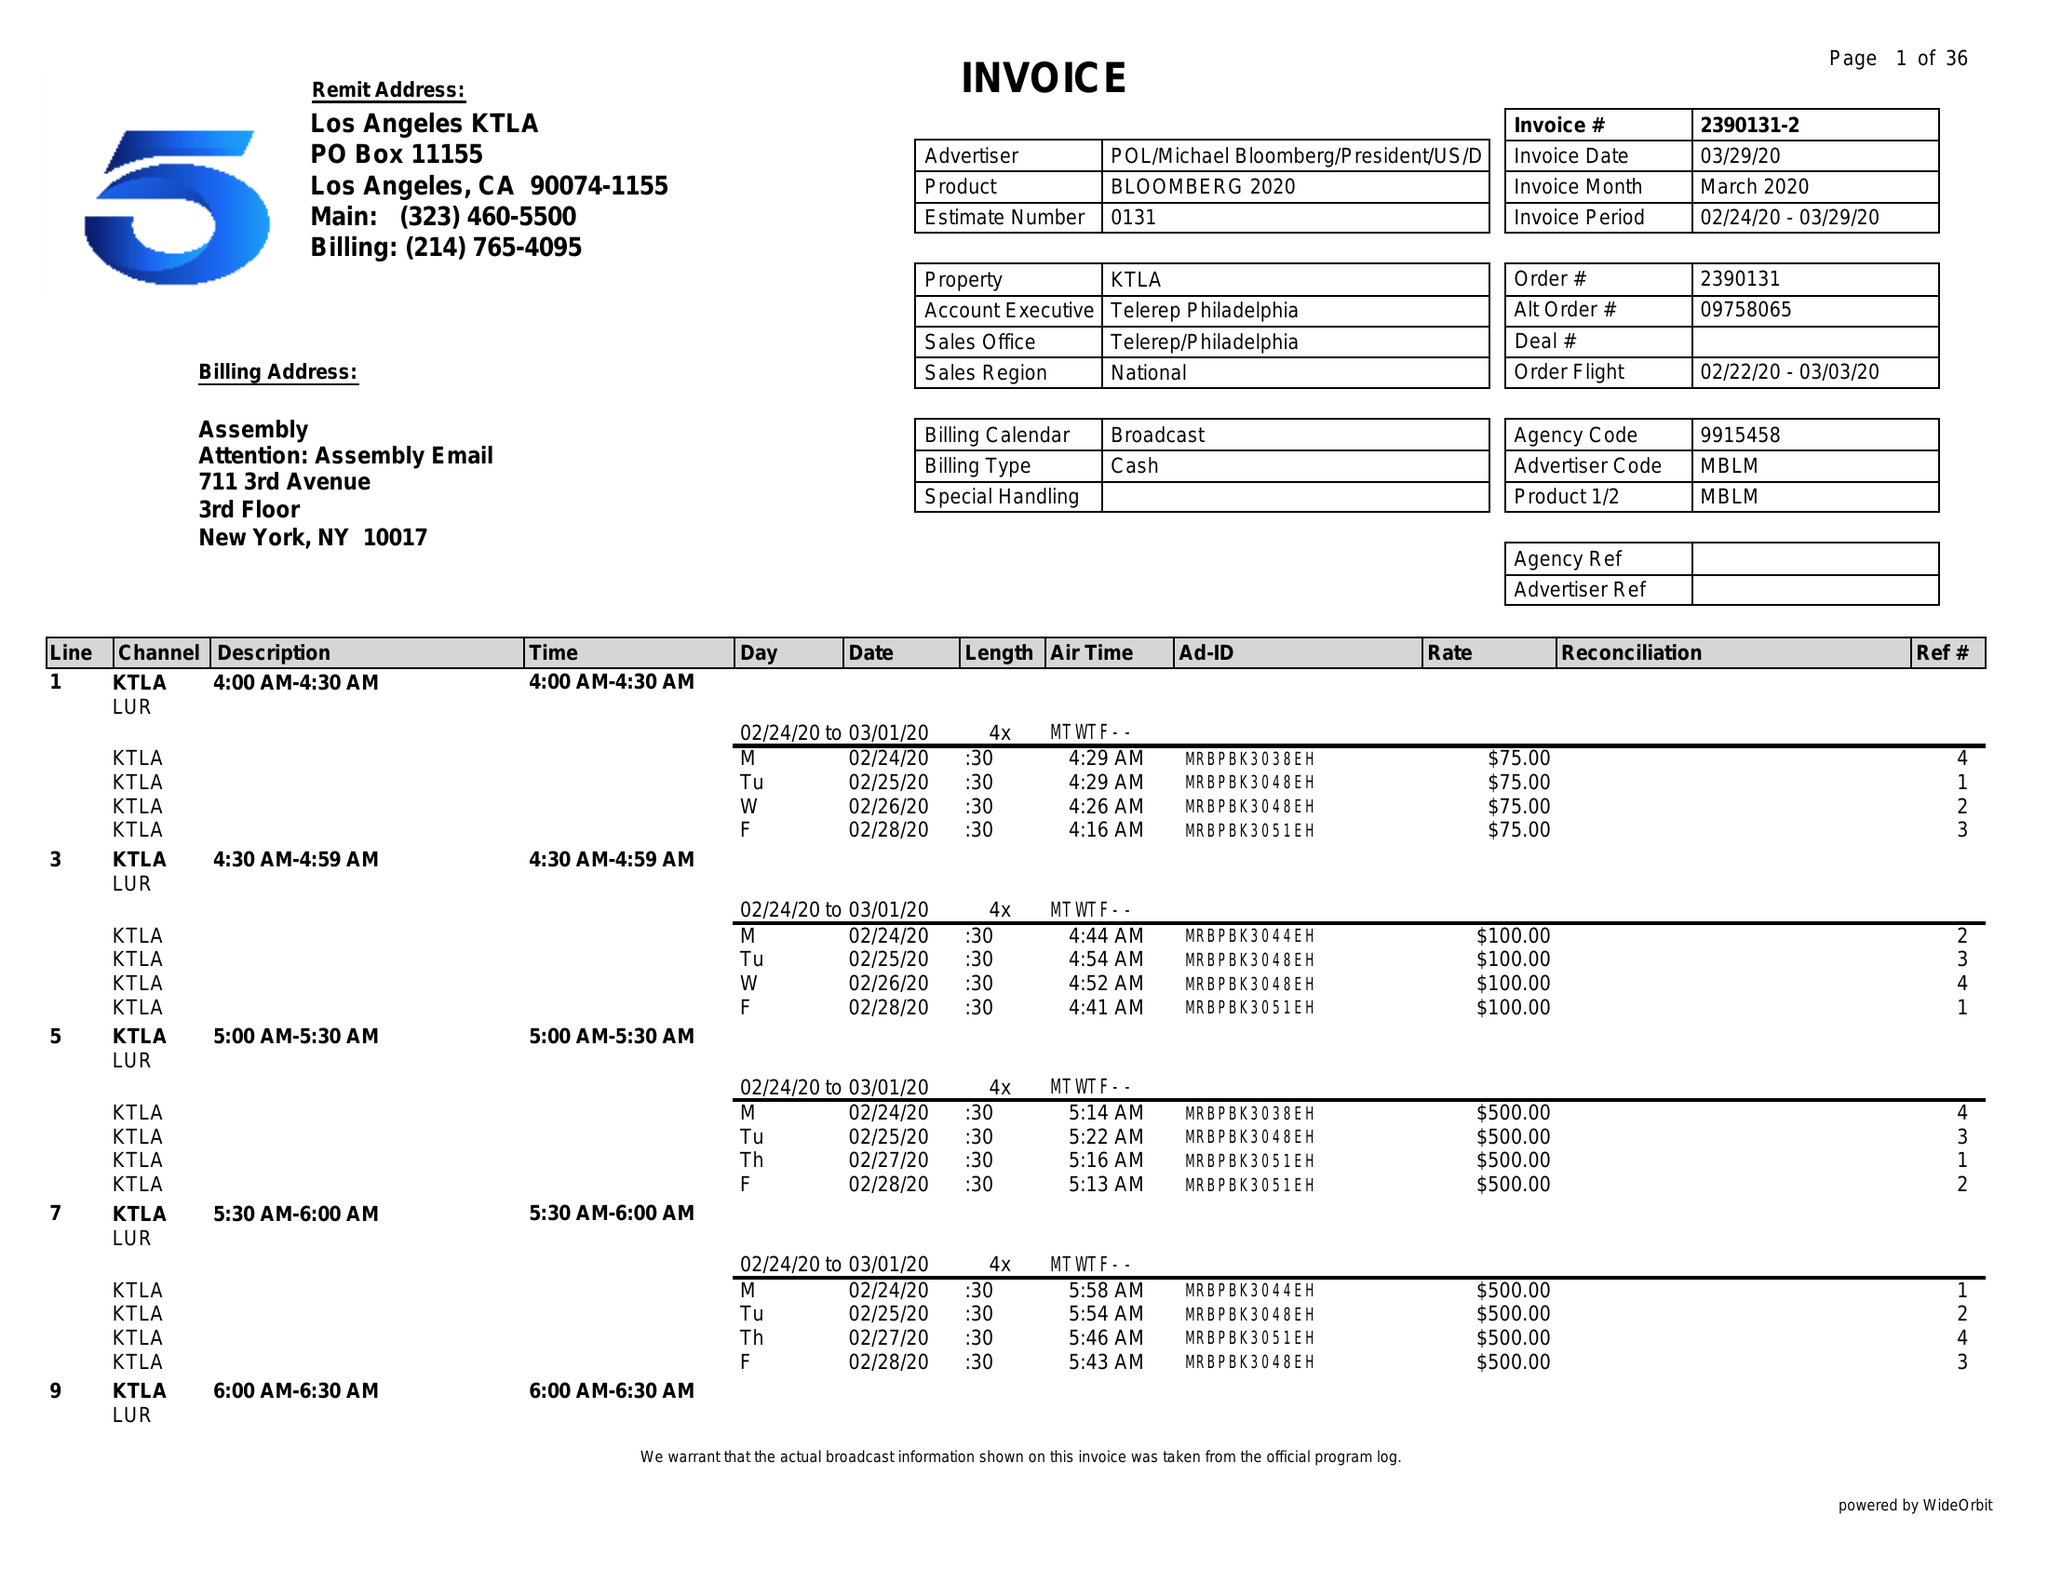What is the value for the flight_from?
Answer the question using a single word or phrase. 02/22/20 